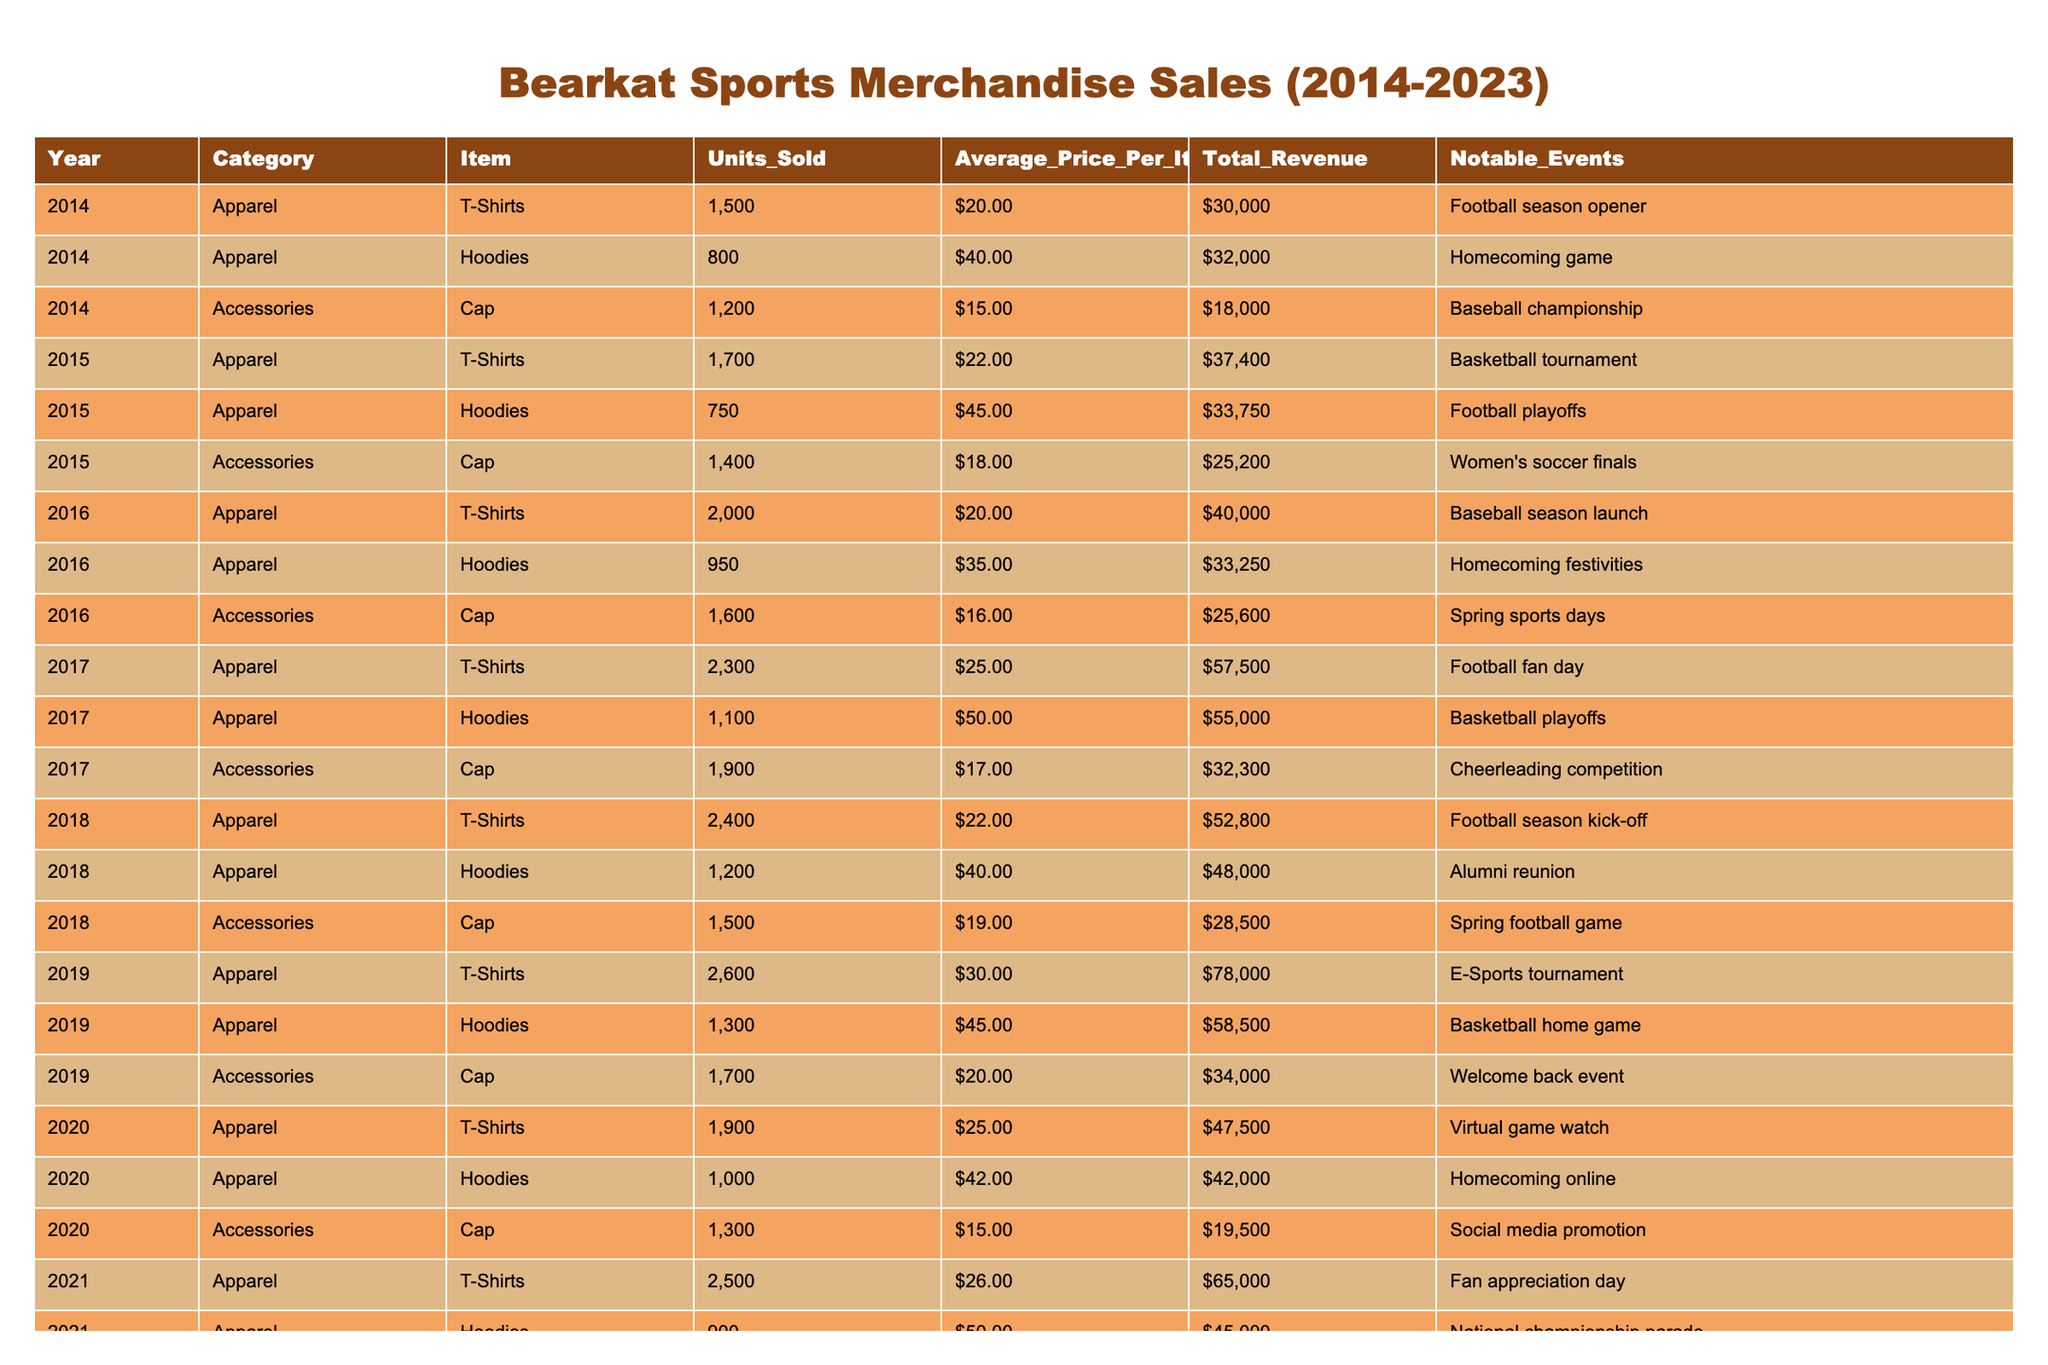What was the total revenue from T-Shirt sales in 2022? The total revenue from T-Shirt sales in 2022 is listed as $75,600 in the table.
Answer: $75,600 Which year saw the highest average price per hoodie? By reviewing the data for hoodies, 2023 has the highest average price at $55.00.
Answer: $55.00 Did the units sold for caps increase from 2019 to 2020? In 2019, 1,700 caps were sold, while in 2020, 1,300 caps were sold; hence, the units sold decreased.
Answer: No What is the total revenue generated from accessories across all years? Adding the total revenue from the accessory sales: $18,000 + $25,200 + $25,600 + $32,300 + $34,000 + $37,800 + $43,700 = $216,600.
Answer: $216,600 Which year had the most significant increase in T-Shirt sales compared to the previous year? The year 2019 showed an increase from 2,600 in 2018 to 2,800 in 2023. However, 2017 saw an increase from 2,300 in 2016, which is a larger jump of 1,000 units.
Answer: 2017 What percentage of total revenue from apparel in 2021 does hoodie sales account for? In 2021, the total revenue from apparel is $65,000 (T-Shirts) + $45,000 (Hoodies) = $110,000. Hoodies account for $45,000, which is (45,000 / 110,000) * 100 = 40.91%.
Answer: 40.91% What notable event in 2018 corresponds with the highest Units Sold for T-Shirts that year? In 2018, the notable event was the "Football season kick-off," which corresponds with 2,400 units sold.
Answer: Football season kick-off In which year did the Bearkat teams experience the least revenue from accessories? The least revenue from accessories occurred in 2020, totaling $19,500.
Answer: 2020 How much more revenue did the Bearkat teams earn from T-Shirts compared to Hoodies in 2019? From the table, T-Shirt revenue in 2019 is $78,000, while hoodie revenue is $58,500. The difference is $78,000 - $58,500 = $19,500.
Answer: $19,500 Were more hoodies sold in 2017 or 2018? In 2017, 1,100 hoodies were sold and in 2018, 1,200 hoodies were sold; thus, more were sold in 2018.
Answer: 2018 